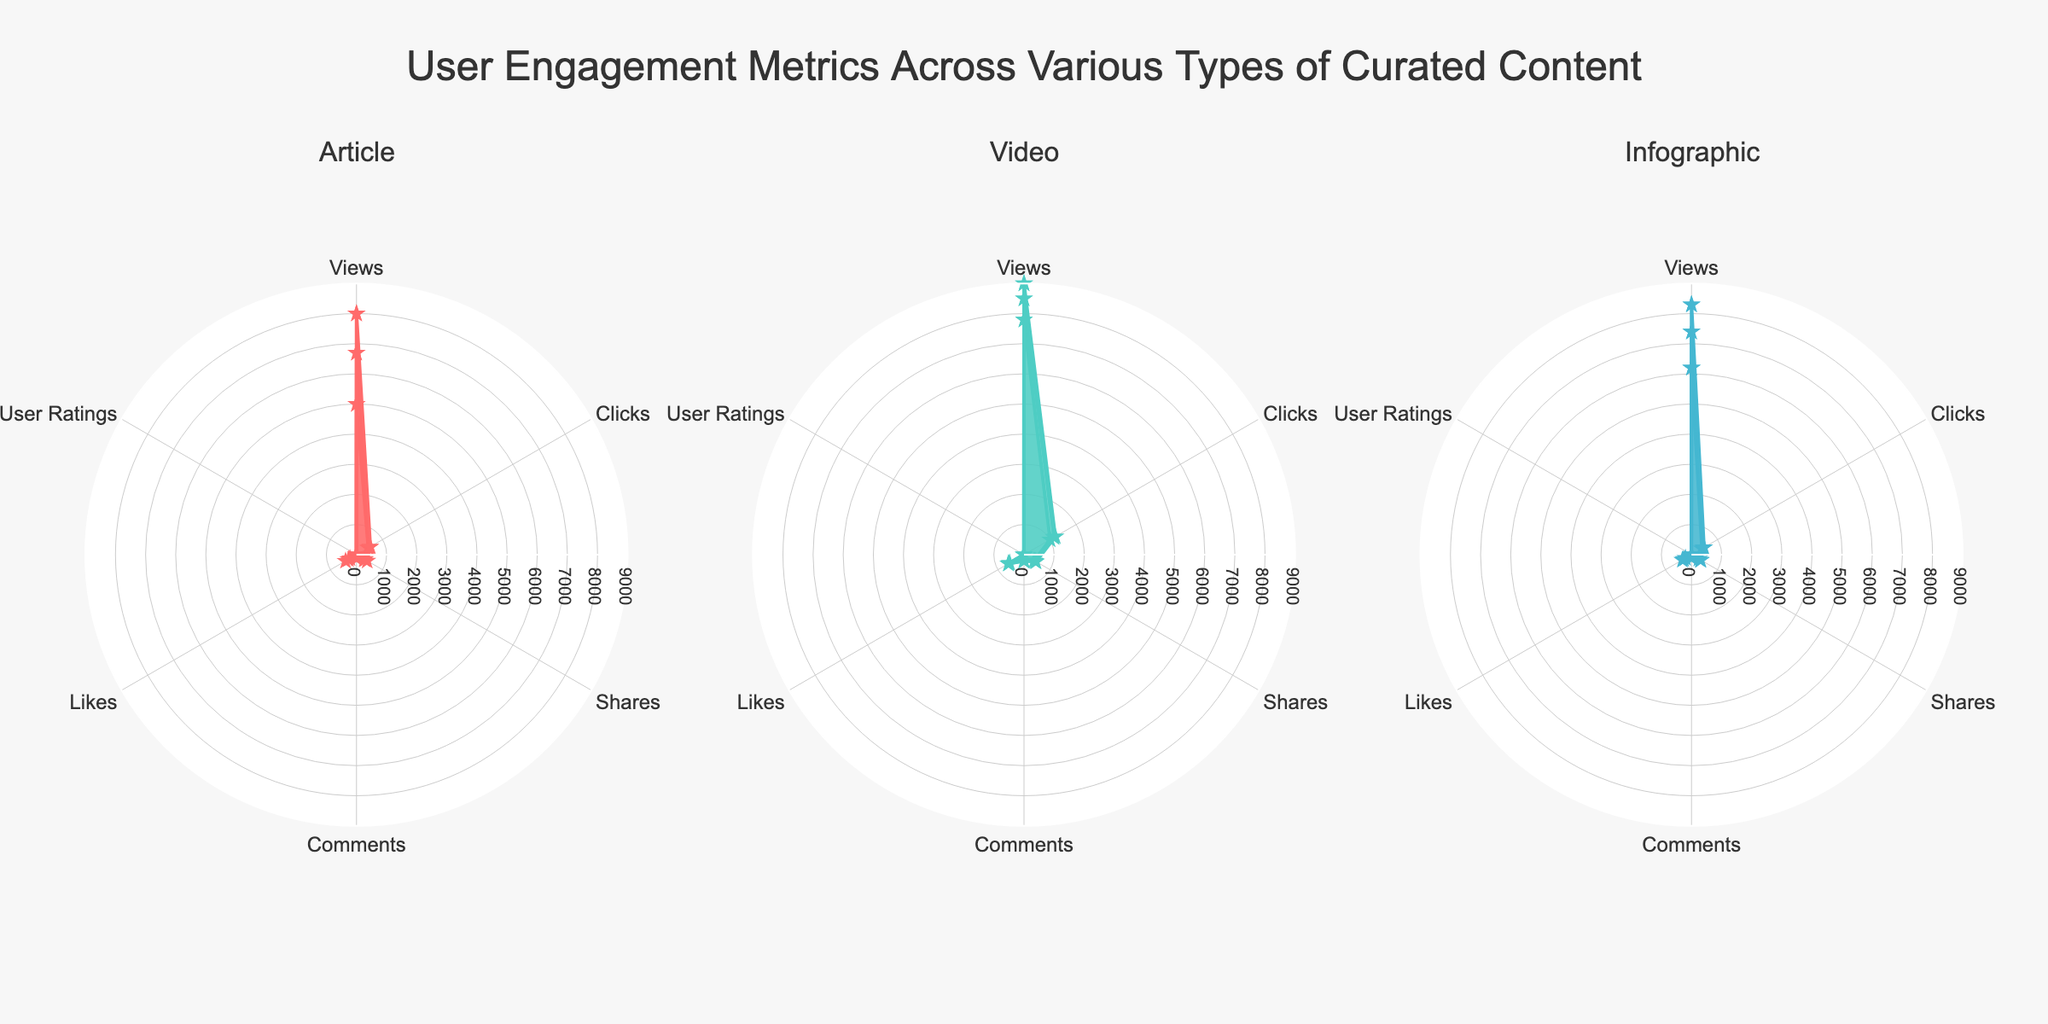How many types of curated content are compared in the radar charts? There are three types of curated content: 'Articles', 'Videos', and 'Infographics'. These are the three titles of the individual radar charts.
Answer: 3 Which "Article" has the highest number of Views? Among the articles compared, "Quantum Computing Advances" has the highest number of Views. This information can be observed from the radar chart for Articles by looking at the topmost value on the Views axis.
Answer: Quantum Computing Advances Which type of curated content generally has the highest User Ratings? The radar charts for each content type show User Ratings. By comparing the outermost ring in each chart, it is evident that ‘Articles’ and ‘Videos’ have similarly high User Ratings, but 'Quantum Computing Advances' holds the highest rating at 4.8.
Answer: Articles and Videos For the "5G and Future Connectivity" video, what is the approximate number of Likes? In the radar chart for Videos, by observing the data point corresponding to Likes for "5G and Future Connectivity," we can see that it is close to 590.
Answer: 590 Compare the Comments for "Cyberattack Statistics 2022" (Infographic) and "Cybersecurity Threats in 2023" (Article). Which one has more? By looking at the radar charts for Infographics and Articles, the "Cyberattack Statistics 2022" has 85 Comments whereas "Cybersecurity Threats in 2023" has 92 Comments. Therefore, "Cybersecurity Threats in 2023" has more Comments.
Answer: Cybersecurity Threats in 2023 Which content type has the widest variation in Clicks among its items? By comparing the range of the 'Clicks' values across the radar charts, ‘Videos’ show the widest range, from 1000 to 1200, indicating the largest variation.
Answer: Videos Identify the content item with the highest Shares value and its type. By checking the outermost data point for Shares in each radar chart, the "Introduction to Blockchain" video has the highest value at 460 shares.
Answer: Introduction to Blockchain, Video Calculate the sum of Likes for all "Infographics" shown in the subplot. Summing up the Likes for all infographics: 230 (Comparative AI Technologies) + 300 (Cyberattack Statistics 2022) + 350 (Evolution of Machine Learning) gives a total of 880.
Answer: 880 